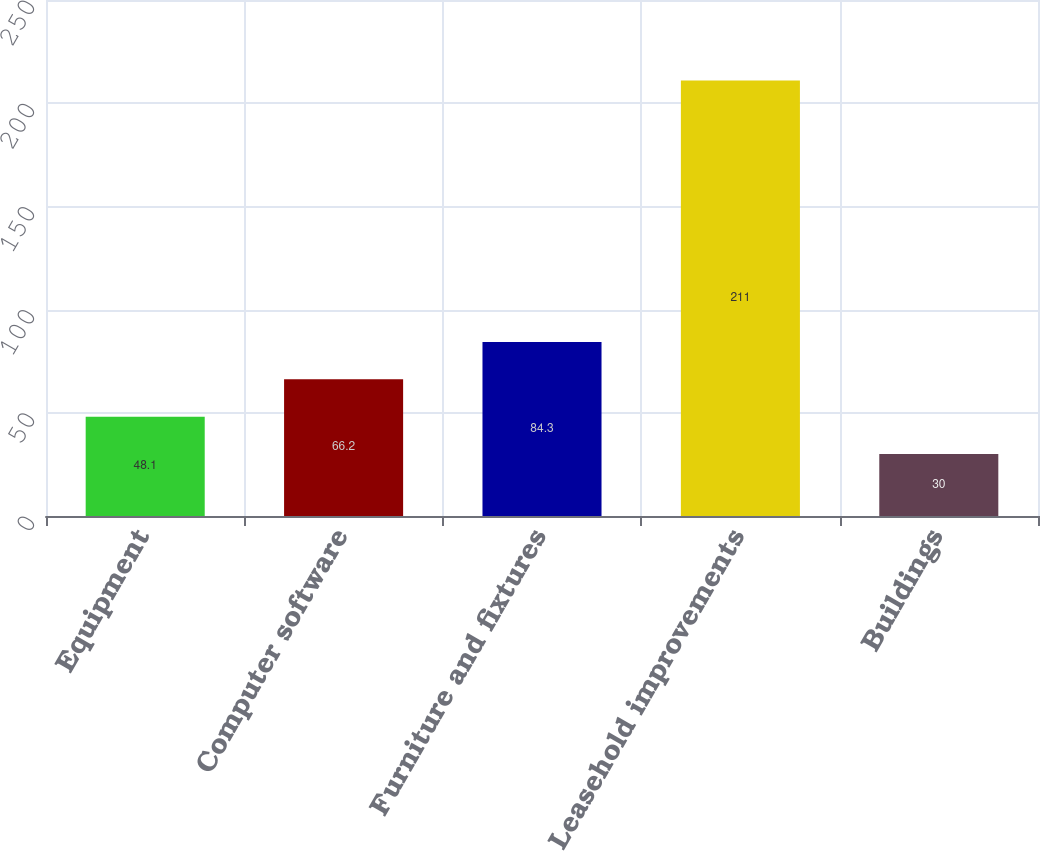Convert chart. <chart><loc_0><loc_0><loc_500><loc_500><bar_chart><fcel>Equipment<fcel>Computer software<fcel>Furniture and fixtures<fcel>Leasehold improvements<fcel>Buildings<nl><fcel>48.1<fcel>66.2<fcel>84.3<fcel>211<fcel>30<nl></chart> 